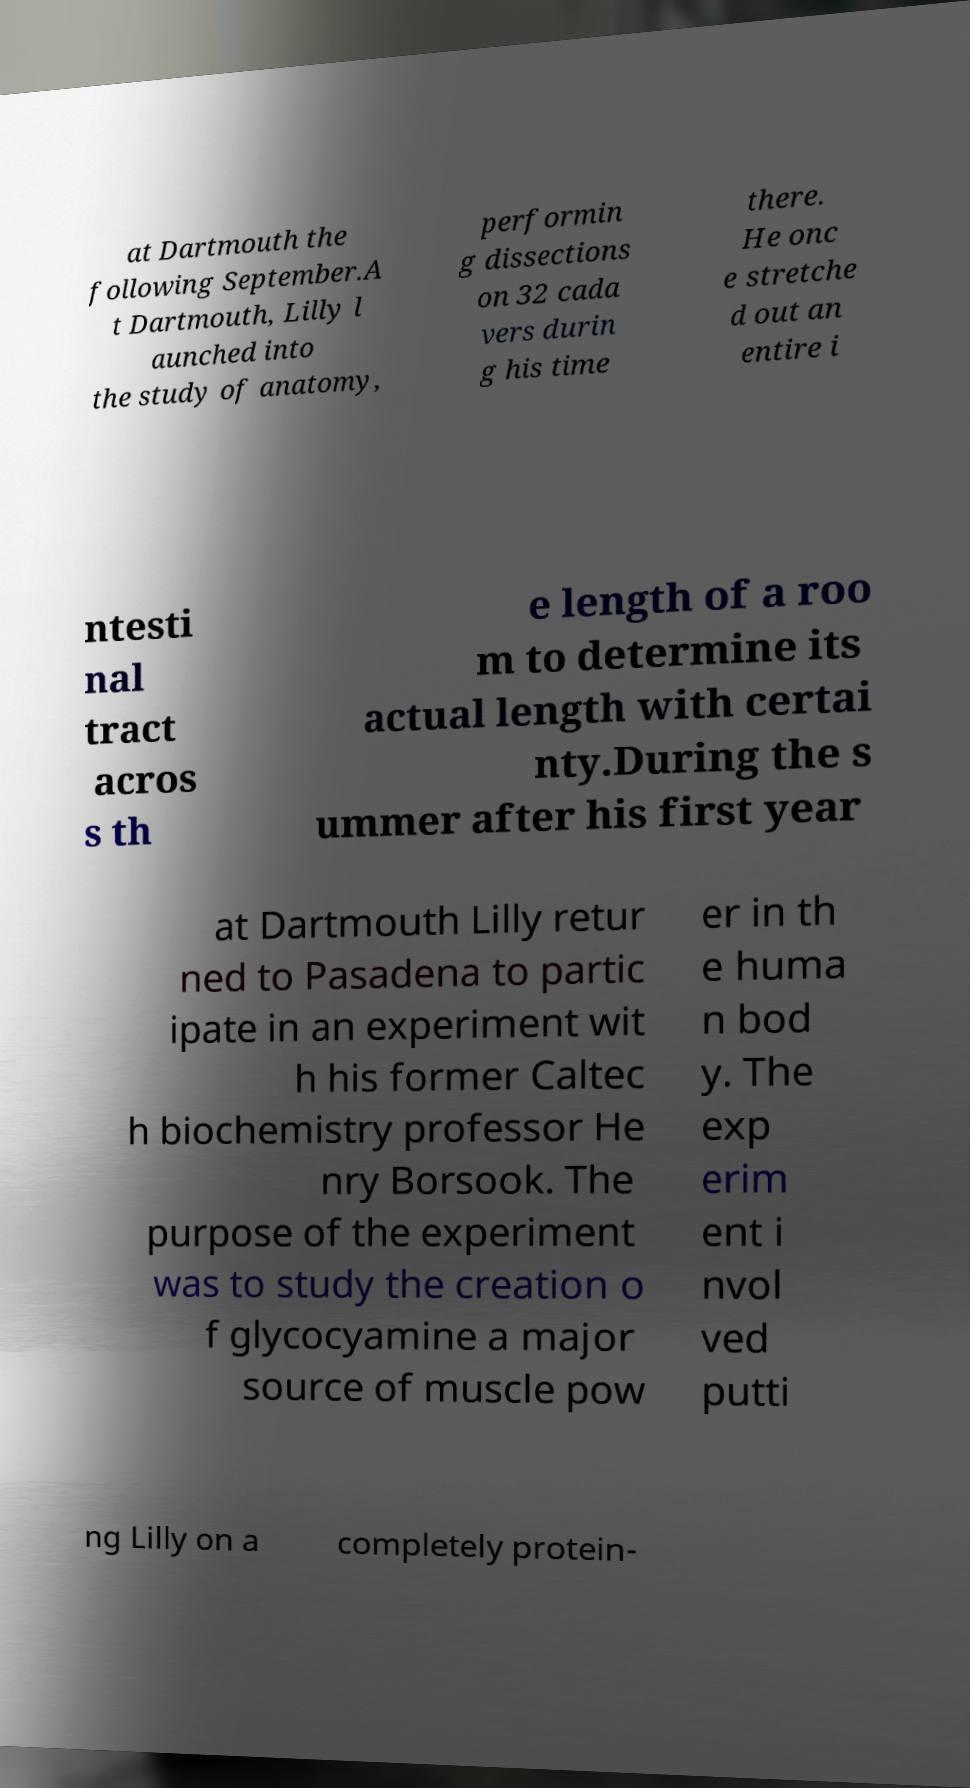Could you assist in decoding the text presented in this image and type it out clearly? at Dartmouth the following September.A t Dartmouth, Lilly l aunched into the study of anatomy, performin g dissections on 32 cada vers durin g his time there. He onc e stretche d out an entire i ntesti nal tract acros s th e length of a roo m to determine its actual length with certai nty.During the s ummer after his first year at Dartmouth Lilly retur ned to Pasadena to partic ipate in an experiment wit h his former Caltec h biochemistry professor He nry Borsook. The purpose of the experiment was to study the creation o f glycocyamine a major source of muscle pow er in th e huma n bod y. The exp erim ent i nvol ved putti ng Lilly on a completely protein- 